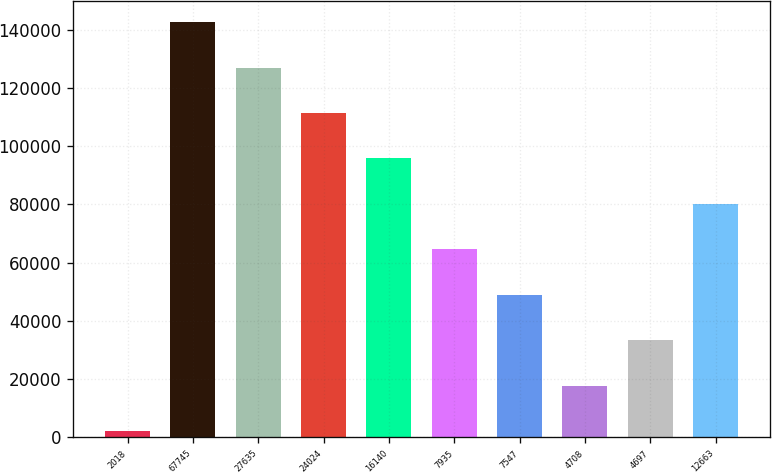<chart> <loc_0><loc_0><loc_500><loc_500><bar_chart><fcel>2018<fcel>67745<fcel>27635<fcel>24024<fcel>16140<fcel>7935<fcel>7547<fcel>4708<fcel>4697<fcel>12663<nl><fcel>2016<fcel>142695<fcel>127064<fcel>111433<fcel>95802<fcel>64540<fcel>48909<fcel>17647<fcel>33278<fcel>80171<nl></chart> 